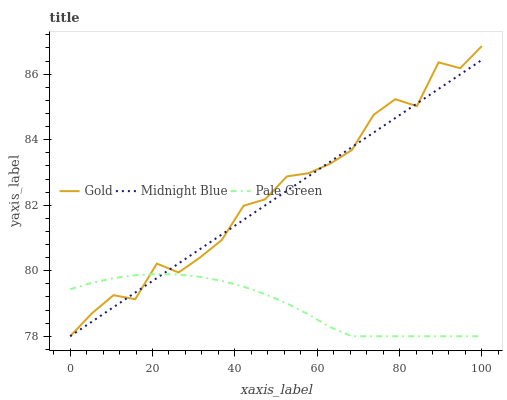Does Pale Green have the minimum area under the curve?
Answer yes or no. Yes. Does Gold have the maximum area under the curve?
Answer yes or no. Yes. Does Midnight Blue have the minimum area under the curve?
Answer yes or no. No. Does Midnight Blue have the maximum area under the curve?
Answer yes or no. No. Is Midnight Blue the smoothest?
Answer yes or no. Yes. Is Gold the roughest?
Answer yes or no. Yes. Is Gold the smoothest?
Answer yes or no. No. Is Midnight Blue the roughest?
Answer yes or no. No. Does Pale Green have the lowest value?
Answer yes or no. Yes. Does Gold have the highest value?
Answer yes or no. Yes. Does Midnight Blue have the highest value?
Answer yes or no. No. Does Midnight Blue intersect Gold?
Answer yes or no. Yes. Is Midnight Blue less than Gold?
Answer yes or no. No. Is Midnight Blue greater than Gold?
Answer yes or no. No. 